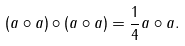<formula> <loc_0><loc_0><loc_500><loc_500>( a \circ a ) \circ ( a \circ a ) = \frac { 1 } { 4 } a \circ a .</formula> 